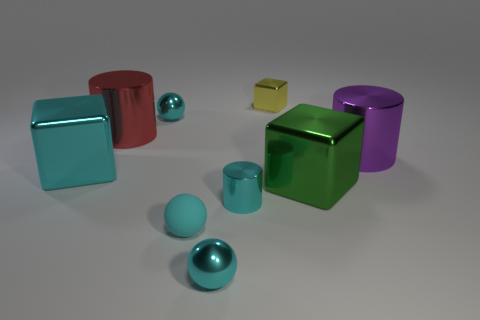How many cyan balls must be subtracted to get 1 cyan balls? 2 Subtract all shiny balls. How many balls are left? 1 Subtract all spheres. How many objects are left? 6 Subtract all red cylinders. How many cylinders are left? 2 Subtract 2 spheres. How many spheres are left? 1 Subtract all green blocks. How many blue spheres are left? 0 Subtract all tiny cyan things. Subtract all small yellow objects. How many objects are left? 4 Add 8 matte spheres. How many matte spheres are left? 9 Add 4 large gray cylinders. How many large gray cylinders exist? 4 Subtract 1 yellow cubes. How many objects are left? 8 